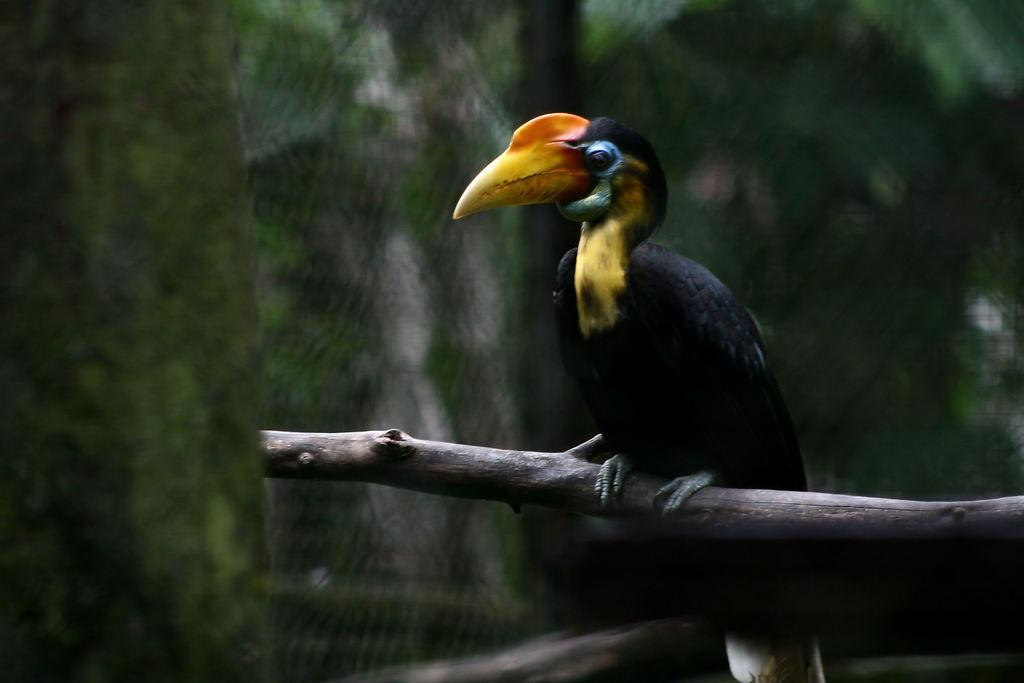What type of animal is in the image? There is a bird in the image. How is the bird positioned in the image? The bird is on a stick. Can you describe the background of the image? The background of the image is blurry. What type of trick is the bird performing on the grandfather in the image? There is no grandfather or trick present in the image; it only features a bird on a stick with a blurry background. 